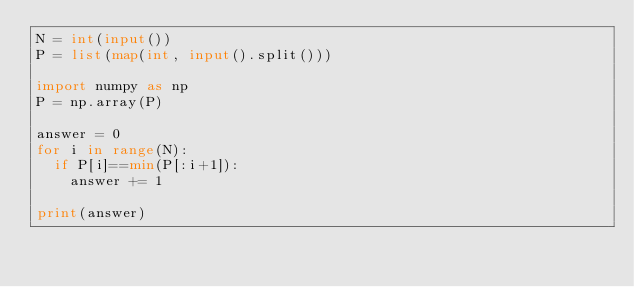<code> <loc_0><loc_0><loc_500><loc_500><_Python_>N = int(input())
P = list(map(int, input().split()))

import numpy as np
P = np.array(P)

answer = 0
for i in range(N):
  if P[i]==min(P[:i+1]):
    answer += 1
    
print(answer)
    </code> 